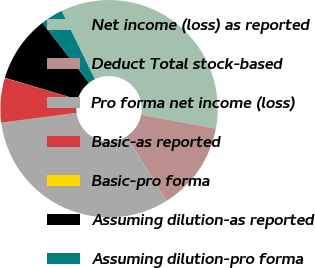Convert chart. <chart><loc_0><loc_0><loc_500><loc_500><pie_chart><fcel>Net income (loss) as reported<fcel>Deduct Total stock-based<fcel>Pro forma net income (loss)<fcel>Basic-as reported<fcel>Basic-pro forma<fcel>Assuming dilution-as reported<fcel>Assuming dilution-pro forma<nl><fcel>35.12%<fcel>13.19%<fcel>31.83%<fcel>6.61%<fcel>0.04%<fcel>9.9%<fcel>3.32%<nl></chart> 